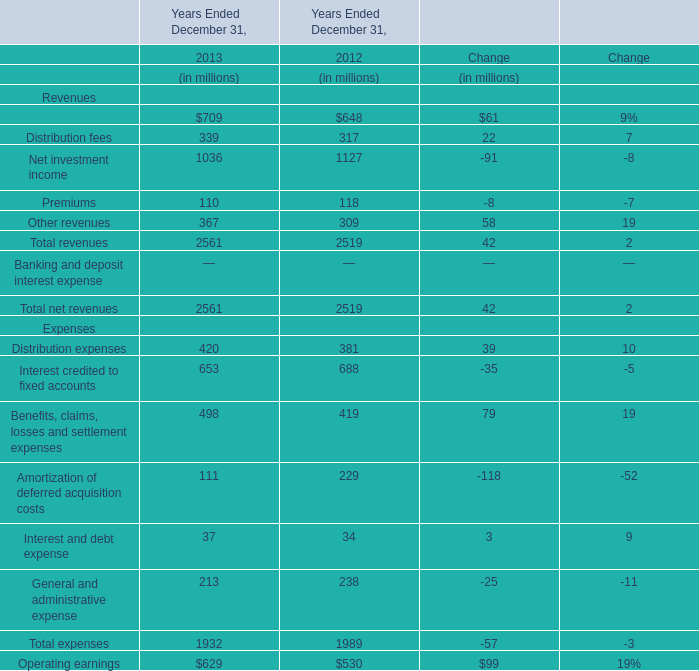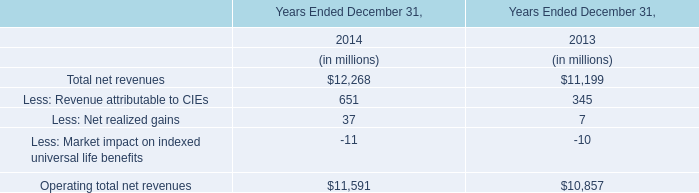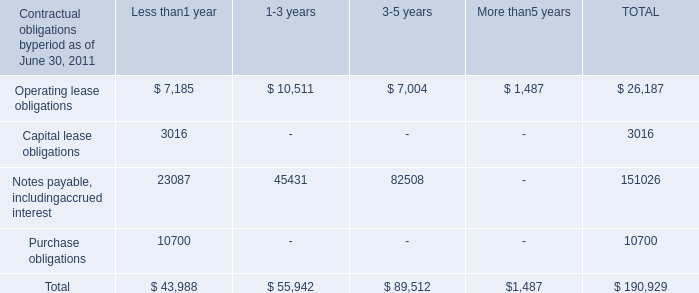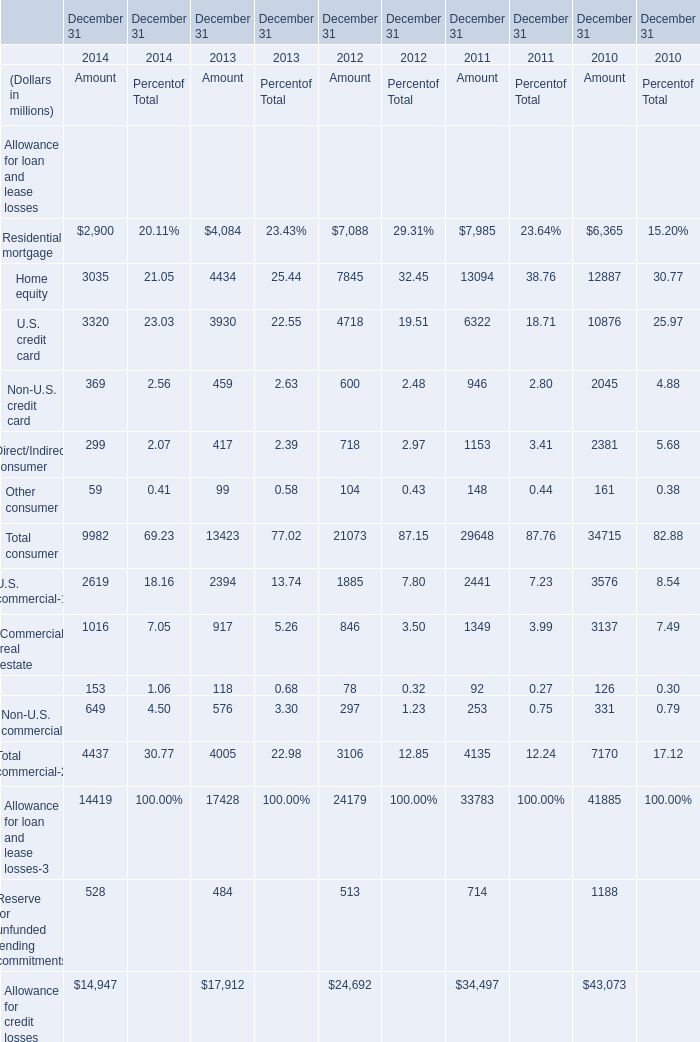In what year is Home equity greater than 13000? 
Answer: 2011. 